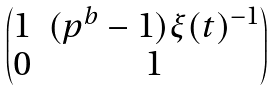Convert formula to latex. <formula><loc_0><loc_0><loc_500><loc_500>\begin{pmatrix} 1 & ( p ^ { b } - 1 ) \xi ( t ) ^ { - 1 } \\ 0 & 1 \end{pmatrix}</formula> 